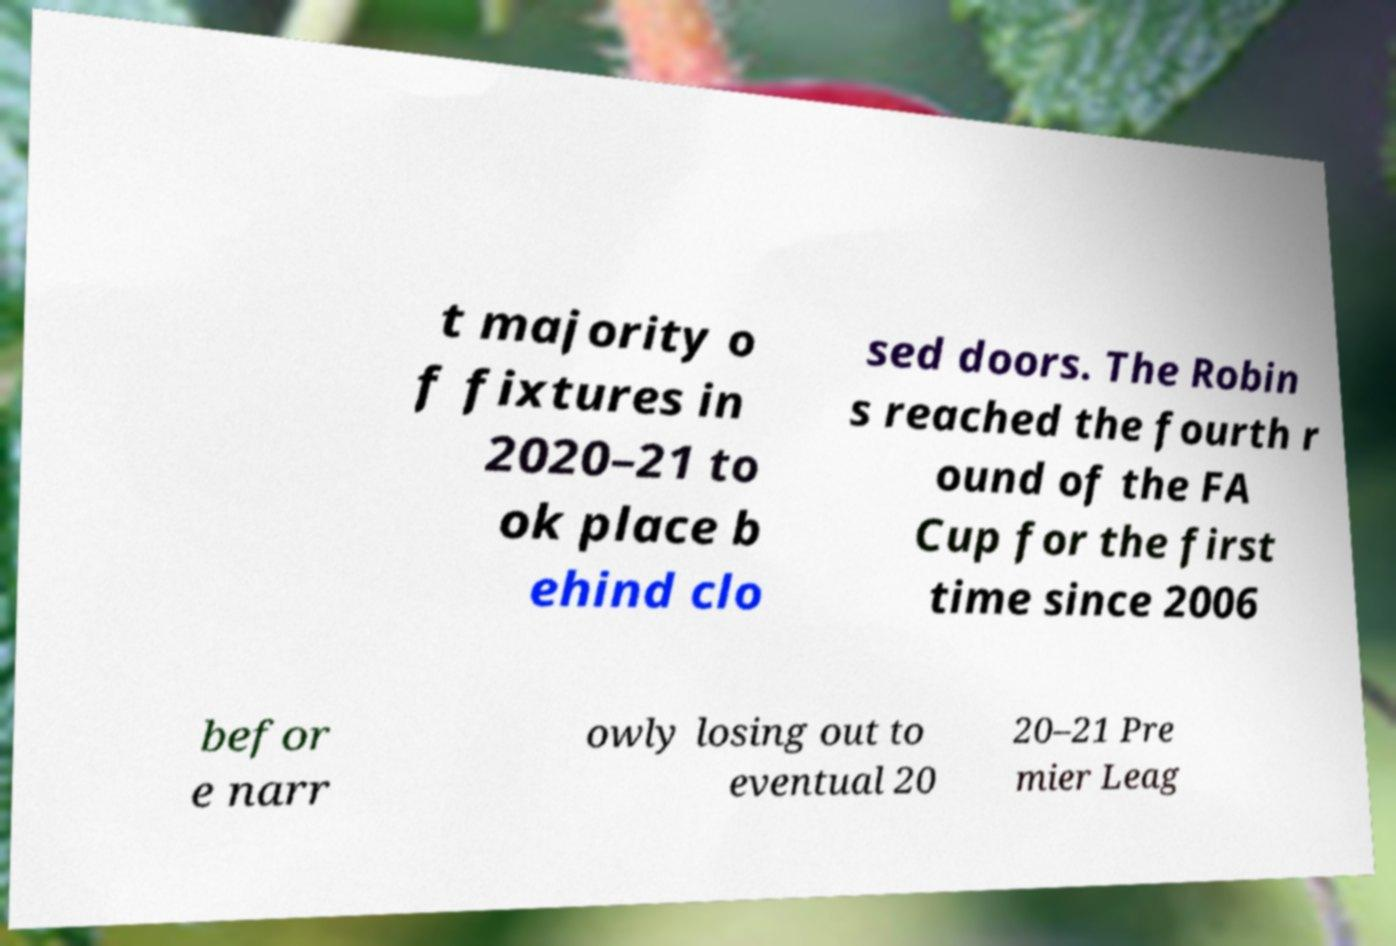Please read and relay the text visible in this image. What does it say? t majority o f fixtures in 2020–21 to ok place b ehind clo sed doors. The Robin s reached the fourth r ound of the FA Cup for the first time since 2006 befor e narr owly losing out to eventual 20 20–21 Pre mier Leag 